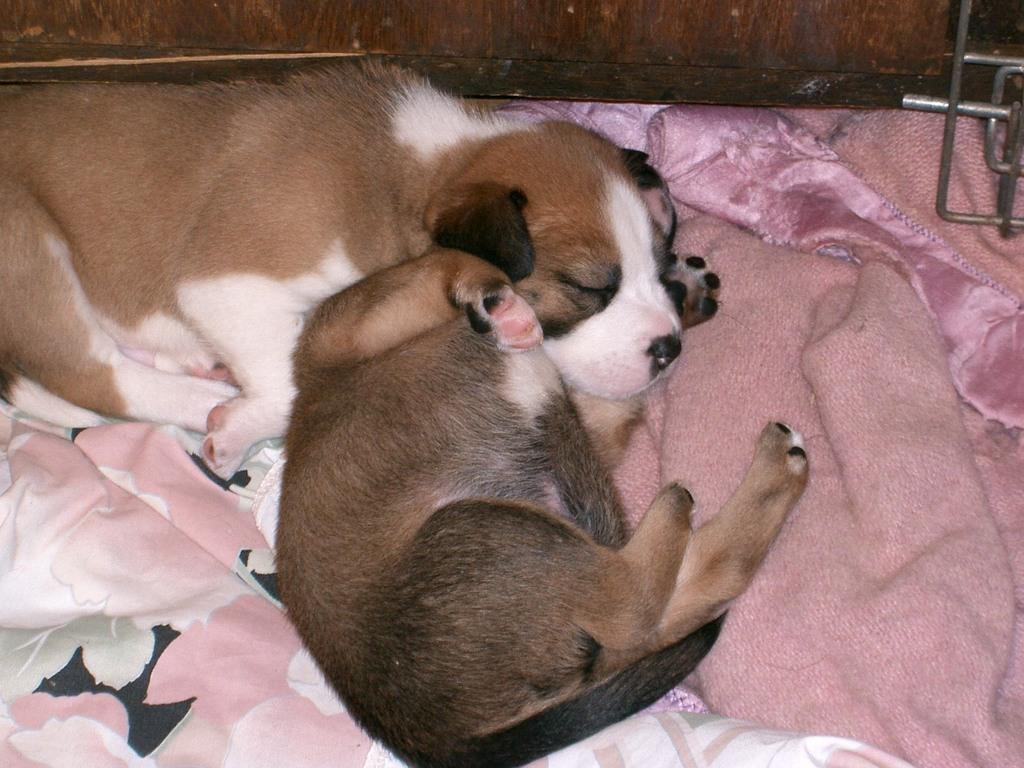How many animals are present in the image? There are two puppies in the image. What are the puppies resting on? The puppies are on a blanket. What type of material can be seen in the background of the image? There is a wooden wall in the background of the image. What type of pear is hanging from the wooden wall in the image? There is no pear present in the image; it features two puppies on a blanket with a wooden wall in the background. 